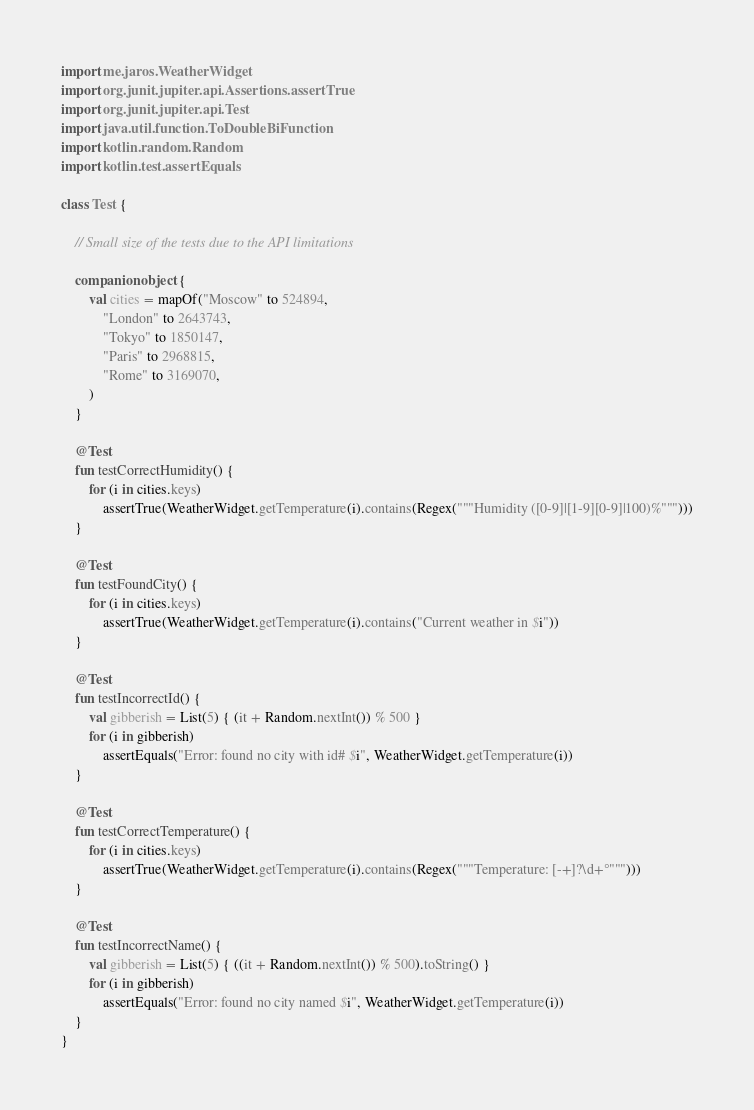<code> <loc_0><loc_0><loc_500><loc_500><_Kotlin_>import me.jaros.WeatherWidget
import org.junit.jupiter.api.Assertions.assertTrue
import org.junit.jupiter.api.Test
import java.util.function.ToDoubleBiFunction
import kotlin.random.Random
import kotlin.test.assertEquals

class Test {

    // Small size of the tests due to the API limitations

    companion object {
        val cities = mapOf("Moscow" to 524894,
            "London" to 2643743,
            "Tokyo" to 1850147,
            "Paris" to 2968815,
            "Rome" to 3169070,
        )
    }

    @Test
    fun testCorrectHumidity() {
        for (i in cities.keys)
            assertTrue(WeatherWidget.getTemperature(i).contains(Regex("""Humidity ([0-9]|[1-9][0-9]|100)%""")))
    }

    @Test
    fun testFoundCity() {
        for (i in cities.keys)
            assertTrue(WeatherWidget.getTemperature(i).contains("Current weather in $i"))
    }

    @Test
    fun testIncorrectId() {
        val gibberish = List(5) { (it + Random.nextInt()) % 500 }
        for (i in gibberish)
            assertEquals("Error: found no city with id# $i", WeatherWidget.getTemperature(i))
    }

    @Test
    fun testCorrectTemperature() {
        for (i in cities.keys)
            assertTrue(WeatherWidget.getTemperature(i).contains(Regex("""Temperature: [-+]?\d+°""")))
    }

    @Test
    fun testIncorrectName() {
        val gibberish = List(5) { ((it + Random.nextInt()) % 500).toString() }
        for (i in gibberish)
            assertEquals("Error: found no city named $i", WeatherWidget.getTemperature(i))
    }
}</code> 